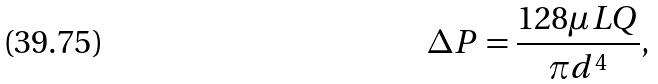<formula> <loc_0><loc_0><loc_500><loc_500>\Delta P = { \frac { 1 2 8 \mu L Q } { \pi d ^ { 4 } } } ,</formula> 